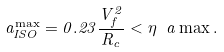Convert formula to latex. <formula><loc_0><loc_0><loc_500><loc_500>a _ { I S O } ^ { \max } = 0 . 2 3 \frac { V _ { f } ^ { 2 } } { R _ { c } } < \eta \ a \max .</formula> 